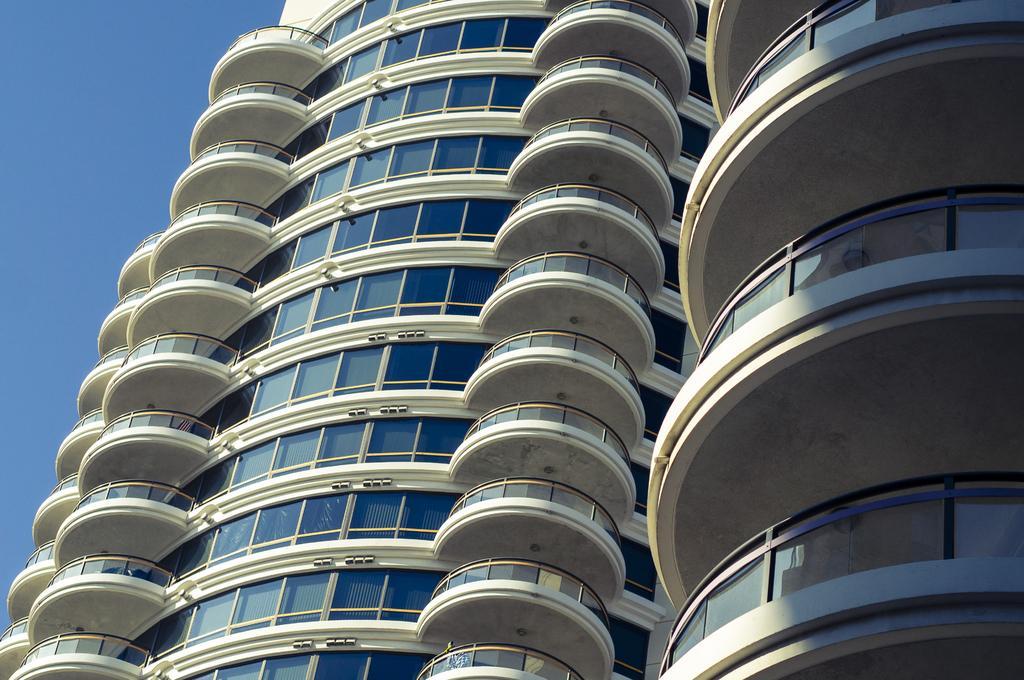In one or two sentences, can you explain what this image depicts? In this image we can see some buildings with glasses and other objects. On the left side of the image there is the sky. 